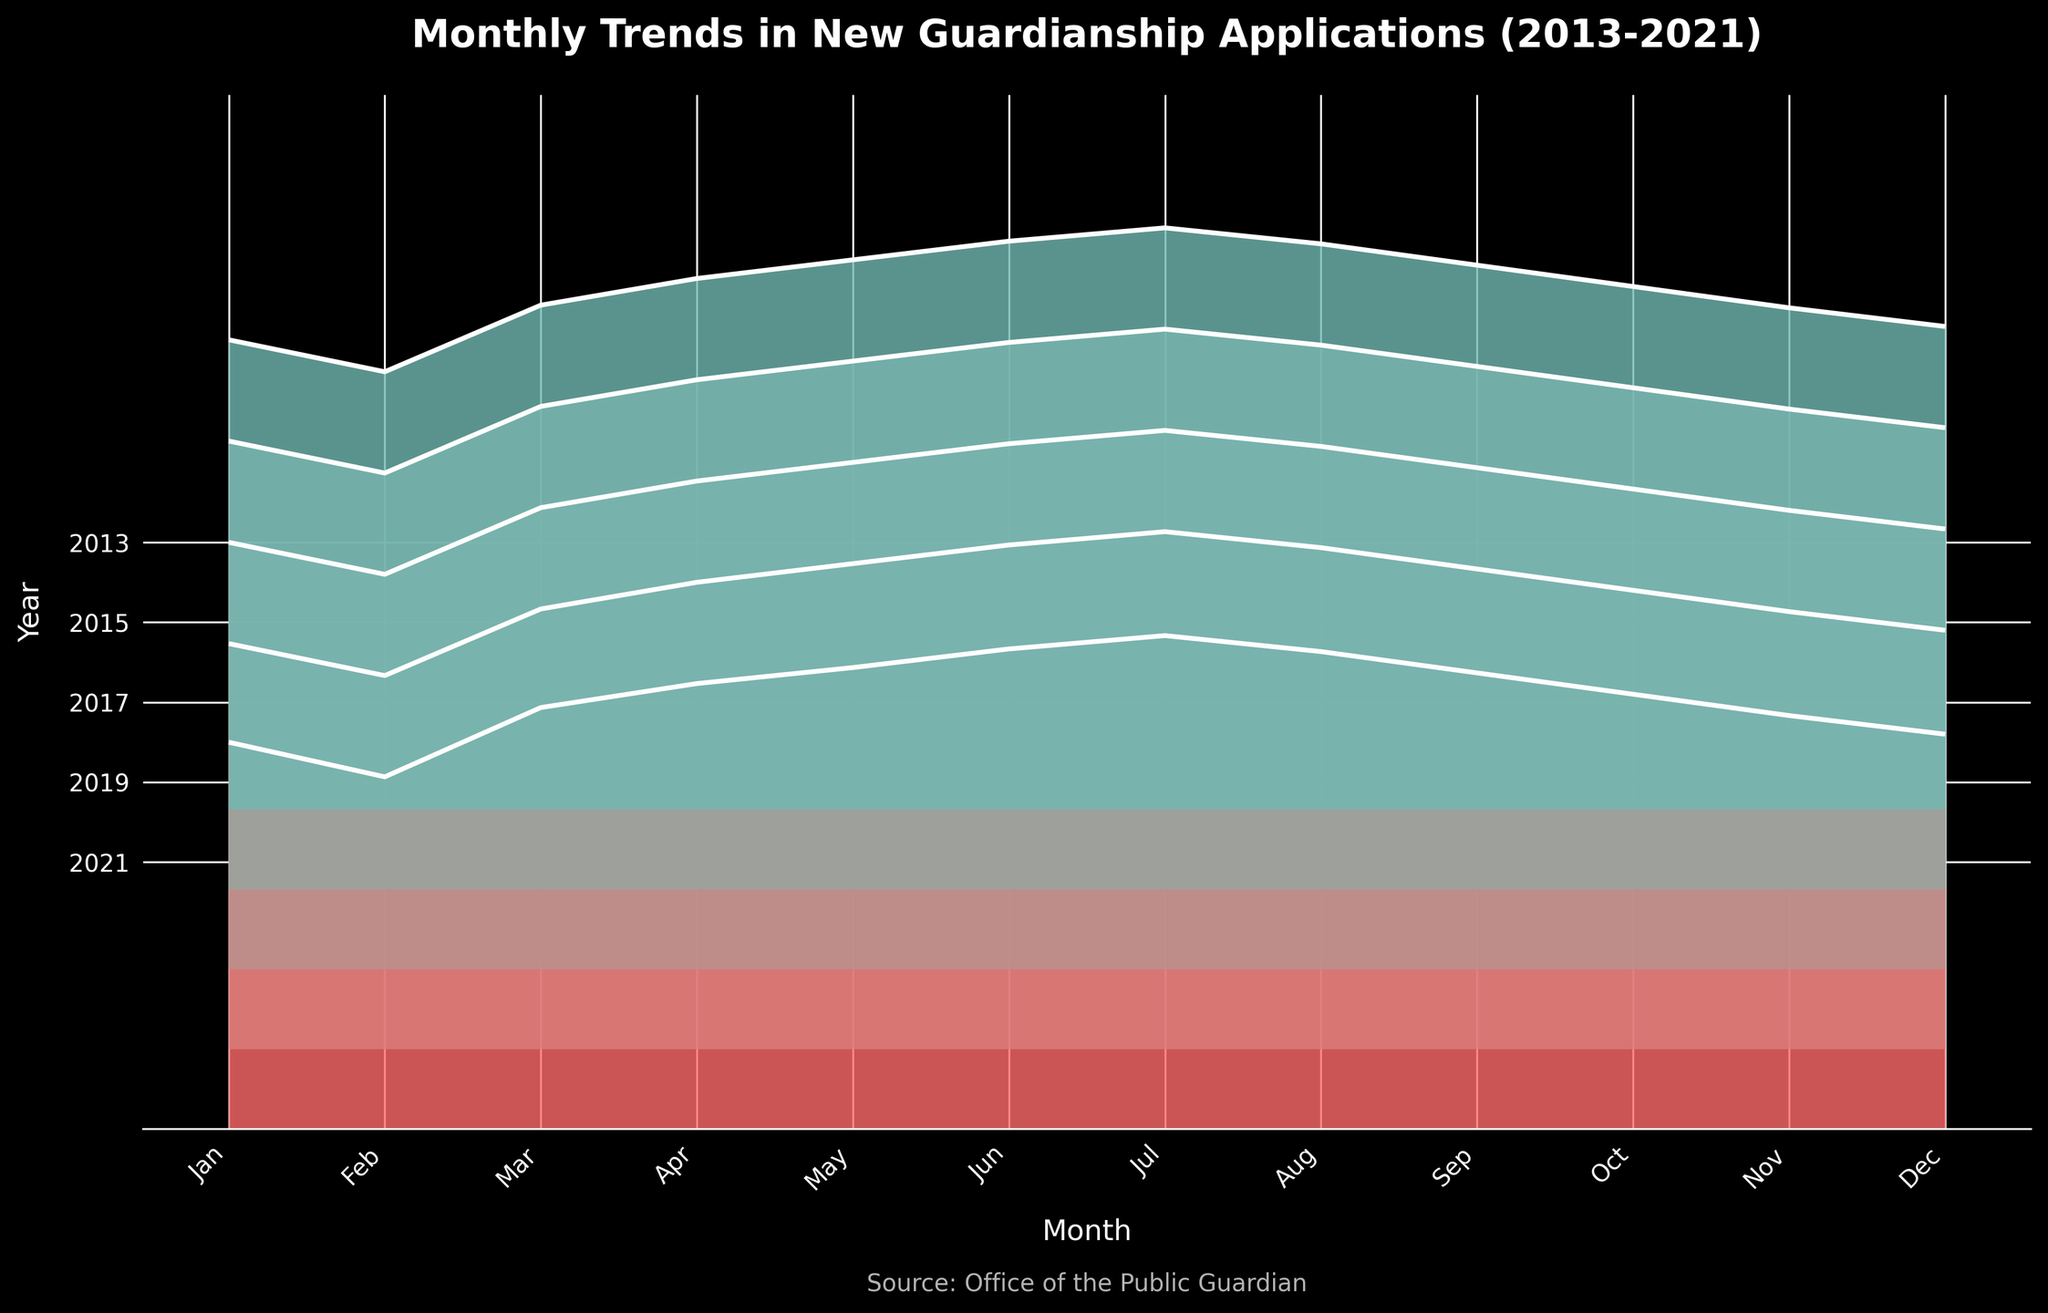What is the title of the chart? The title of the chart is usually located at the top and it provides an overview or main point of the chart. The title here should be the one given in the plotting code.
Answer: Monthly Trends in New Guardianship Applications (2013-2021) What do the x-axis and y-axis represent in this chart? The x-axis typically represents the categories or values being compared, whereas the y-axis often represents the values of those categories. In this ridgeline plot, the x-axis labels are months and the y-axis labels are years.
Answer: The x-axis represents months and the y-axis represents years Which year had the highest peak in guardianship applications? To find the highest peak, identify the tallest curve across all the ridgelines in the plot. Each ridgeline corresponds to a year, and the highest point among them represents the maximum applications in that year.
Answer: 2021 What color pattern is used to represent different years in the graph? The color pattern in the ridgeline plot usually changes gradually to visually separate different years. The custom color map mentioned transitions from one color to another to represent the different years.
Answer: A gradient from red to teal is used How do the application trends for the month of July evolve from 2013 to 2021? To see the evolution of July applications, locate all the points corresponding to July (on the x-axis) across the years (on the y-axis), and observe the pattern or trend, particularly if they rise, fall, or show consistent fluctuations.
Answer: They show a steady increase Which month in 2013 had the lowest number of applications? To find the month with the lowest number of applications in 2013, look for the smallest peak on the 2013 ridgeline.
Answer: February Compare the general trend in the number of applications between 2013 and 2021. For comparison, observe the ridgelines corresponding to 2013 and 2021. Look at the shape and height of the applications across months to identify whether there is an upward or downward trend.
Answer: There is a general upward trend What is the range of applications for June across all the years shown? To find the range, identify the data points corresponding to June across all the ridgelines and calculate the difference between the maximum and minimum values.
Answer: The range is from 180 to 213 On average, did the number of applications in December increase or decrease over the years? Calculate the average number of applications for December by summing the applications in December across all years and dividing by the number of years to see if there is a general increasing or decreasing pattern.
Answer: It increased What is the unique feature of the ridgeline plot that helps in visualizing trends over multiple years? Ridgeline plots stack multiple density plots (or ridgelines) on top of each other which effectively showcases trends over time across different categories.
Answer: The stacking of multiple years' data for easy trend comparison 